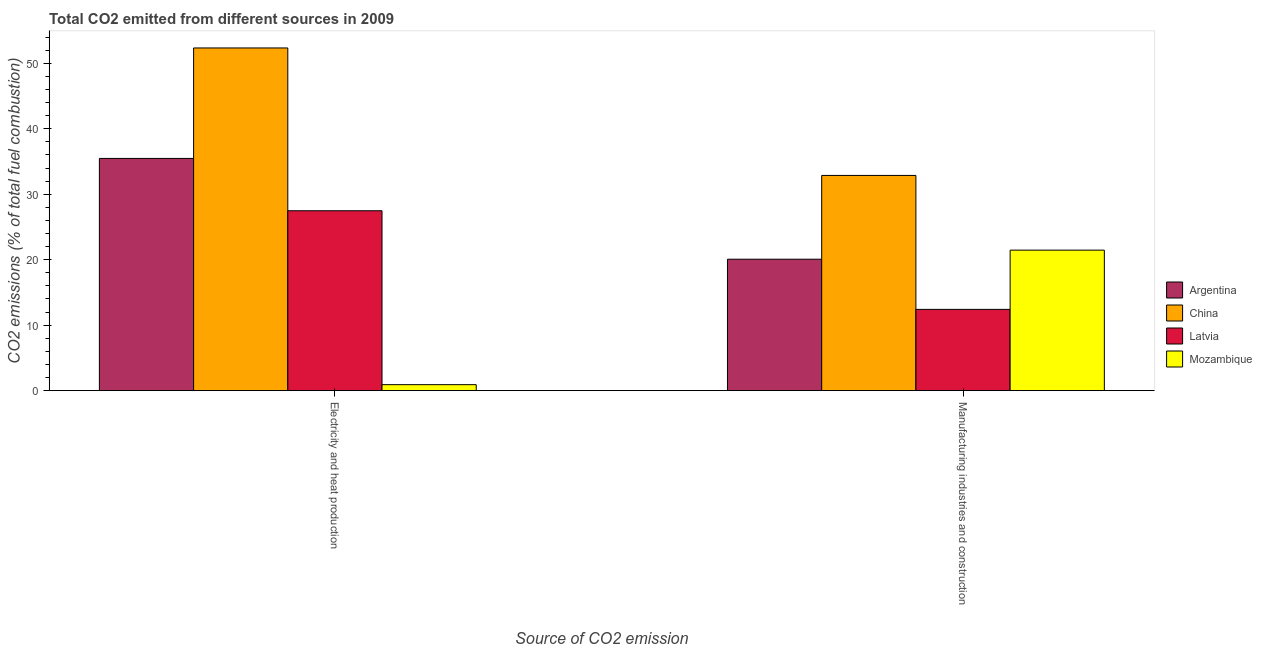How many different coloured bars are there?
Provide a short and direct response. 4. How many groups of bars are there?
Provide a short and direct response. 2. Are the number of bars per tick equal to the number of legend labels?
Provide a short and direct response. Yes. How many bars are there on the 1st tick from the left?
Give a very brief answer. 4. What is the label of the 1st group of bars from the left?
Keep it short and to the point. Electricity and heat production. What is the co2 emissions due to manufacturing industries in China?
Give a very brief answer. 32.87. Across all countries, what is the maximum co2 emissions due to electricity and heat production?
Ensure brevity in your answer.  52.34. Across all countries, what is the minimum co2 emissions due to electricity and heat production?
Give a very brief answer. 0.91. In which country was the co2 emissions due to electricity and heat production minimum?
Offer a terse response. Mozambique. What is the total co2 emissions due to manufacturing industries in the graph?
Offer a very short reply. 86.82. What is the difference between the co2 emissions due to manufacturing industries in China and that in Argentina?
Provide a short and direct response. 12.8. What is the difference between the co2 emissions due to manufacturing industries in Mozambique and the co2 emissions due to electricity and heat production in Latvia?
Make the answer very short. -6.01. What is the average co2 emissions due to manufacturing industries per country?
Your answer should be very brief. 21.71. What is the difference between the co2 emissions due to manufacturing industries and co2 emissions due to electricity and heat production in Argentina?
Provide a succinct answer. -15.39. What is the ratio of the co2 emissions due to electricity and heat production in Latvia to that in China?
Your answer should be compact. 0.52. Is the co2 emissions due to electricity and heat production in Mozambique less than that in Argentina?
Your answer should be very brief. Yes. In how many countries, is the co2 emissions due to manufacturing industries greater than the average co2 emissions due to manufacturing industries taken over all countries?
Keep it short and to the point. 1. What does the 3rd bar from the right in Electricity and heat production represents?
Your answer should be very brief. China. What is the title of the graph?
Give a very brief answer. Total CO2 emitted from different sources in 2009. Does "Germany" appear as one of the legend labels in the graph?
Your answer should be compact. No. What is the label or title of the X-axis?
Make the answer very short. Source of CO2 emission. What is the label or title of the Y-axis?
Your answer should be very brief. CO2 emissions (% of total fuel combustion). What is the CO2 emissions (% of total fuel combustion) of Argentina in Electricity and heat production?
Ensure brevity in your answer.  35.47. What is the CO2 emissions (% of total fuel combustion) of China in Electricity and heat production?
Keep it short and to the point. 52.34. What is the CO2 emissions (% of total fuel combustion) of Latvia in Electricity and heat production?
Offer a terse response. 27.48. What is the CO2 emissions (% of total fuel combustion) in Mozambique in Electricity and heat production?
Your answer should be compact. 0.91. What is the CO2 emissions (% of total fuel combustion) in Argentina in Manufacturing industries and construction?
Offer a very short reply. 20.08. What is the CO2 emissions (% of total fuel combustion) of China in Manufacturing industries and construction?
Keep it short and to the point. 32.87. What is the CO2 emissions (% of total fuel combustion) in Latvia in Manufacturing industries and construction?
Your answer should be compact. 12.41. What is the CO2 emissions (% of total fuel combustion) of Mozambique in Manufacturing industries and construction?
Your answer should be compact. 21.46. Across all Source of CO2 emission, what is the maximum CO2 emissions (% of total fuel combustion) of Argentina?
Keep it short and to the point. 35.47. Across all Source of CO2 emission, what is the maximum CO2 emissions (% of total fuel combustion) of China?
Your response must be concise. 52.34. Across all Source of CO2 emission, what is the maximum CO2 emissions (% of total fuel combustion) of Latvia?
Ensure brevity in your answer.  27.48. Across all Source of CO2 emission, what is the maximum CO2 emissions (% of total fuel combustion) in Mozambique?
Offer a very short reply. 21.46. Across all Source of CO2 emission, what is the minimum CO2 emissions (% of total fuel combustion) in Argentina?
Your answer should be very brief. 20.08. Across all Source of CO2 emission, what is the minimum CO2 emissions (% of total fuel combustion) of China?
Your answer should be compact. 32.87. Across all Source of CO2 emission, what is the minimum CO2 emissions (% of total fuel combustion) in Latvia?
Provide a succinct answer. 12.41. Across all Source of CO2 emission, what is the minimum CO2 emissions (% of total fuel combustion) of Mozambique?
Provide a short and direct response. 0.91. What is the total CO2 emissions (% of total fuel combustion) of Argentina in the graph?
Make the answer very short. 55.54. What is the total CO2 emissions (% of total fuel combustion) in China in the graph?
Offer a terse response. 85.21. What is the total CO2 emissions (% of total fuel combustion) in Latvia in the graph?
Give a very brief answer. 39.89. What is the total CO2 emissions (% of total fuel combustion) in Mozambique in the graph?
Make the answer very short. 22.37. What is the difference between the CO2 emissions (% of total fuel combustion) of Argentina in Electricity and heat production and that in Manufacturing industries and construction?
Your answer should be compact. 15.39. What is the difference between the CO2 emissions (% of total fuel combustion) in China in Electricity and heat production and that in Manufacturing industries and construction?
Your response must be concise. 19.47. What is the difference between the CO2 emissions (% of total fuel combustion) in Latvia in Electricity and heat production and that in Manufacturing industries and construction?
Your response must be concise. 15.06. What is the difference between the CO2 emissions (% of total fuel combustion) of Mozambique in Electricity and heat production and that in Manufacturing industries and construction?
Your answer should be very brief. -20.55. What is the difference between the CO2 emissions (% of total fuel combustion) in Argentina in Electricity and heat production and the CO2 emissions (% of total fuel combustion) in China in Manufacturing industries and construction?
Provide a short and direct response. 2.6. What is the difference between the CO2 emissions (% of total fuel combustion) in Argentina in Electricity and heat production and the CO2 emissions (% of total fuel combustion) in Latvia in Manufacturing industries and construction?
Offer a very short reply. 23.05. What is the difference between the CO2 emissions (% of total fuel combustion) of Argentina in Electricity and heat production and the CO2 emissions (% of total fuel combustion) of Mozambique in Manufacturing industries and construction?
Provide a succinct answer. 14.01. What is the difference between the CO2 emissions (% of total fuel combustion) of China in Electricity and heat production and the CO2 emissions (% of total fuel combustion) of Latvia in Manufacturing industries and construction?
Ensure brevity in your answer.  39.93. What is the difference between the CO2 emissions (% of total fuel combustion) in China in Electricity and heat production and the CO2 emissions (% of total fuel combustion) in Mozambique in Manufacturing industries and construction?
Give a very brief answer. 30.88. What is the difference between the CO2 emissions (% of total fuel combustion) in Latvia in Electricity and heat production and the CO2 emissions (% of total fuel combustion) in Mozambique in Manufacturing industries and construction?
Provide a succinct answer. 6.01. What is the average CO2 emissions (% of total fuel combustion) in Argentina per Source of CO2 emission?
Keep it short and to the point. 27.77. What is the average CO2 emissions (% of total fuel combustion) in China per Source of CO2 emission?
Provide a short and direct response. 42.61. What is the average CO2 emissions (% of total fuel combustion) in Latvia per Source of CO2 emission?
Offer a very short reply. 19.94. What is the average CO2 emissions (% of total fuel combustion) of Mozambique per Source of CO2 emission?
Provide a short and direct response. 11.19. What is the difference between the CO2 emissions (% of total fuel combustion) in Argentina and CO2 emissions (% of total fuel combustion) in China in Electricity and heat production?
Your response must be concise. -16.87. What is the difference between the CO2 emissions (% of total fuel combustion) of Argentina and CO2 emissions (% of total fuel combustion) of Latvia in Electricity and heat production?
Ensure brevity in your answer.  7.99. What is the difference between the CO2 emissions (% of total fuel combustion) of Argentina and CO2 emissions (% of total fuel combustion) of Mozambique in Electricity and heat production?
Keep it short and to the point. 34.55. What is the difference between the CO2 emissions (% of total fuel combustion) of China and CO2 emissions (% of total fuel combustion) of Latvia in Electricity and heat production?
Offer a terse response. 24.86. What is the difference between the CO2 emissions (% of total fuel combustion) in China and CO2 emissions (% of total fuel combustion) in Mozambique in Electricity and heat production?
Provide a succinct answer. 51.43. What is the difference between the CO2 emissions (% of total fuel combustion) of Latvia and CO2 emissions (% of total fuel combustion) of Mozambique in Electricity and heat production?
Your answer should be very brief. 26.56. What is the difference between the CO2 emissions (% of total fuel combustion) of Argentina and CO2 emissions (% of total fuel combustion) of China in Manufacturing industries and construction?
Your response must be concise. -12.8. What is the difference between the CO2 emissions (% of total fuel combustion) of Argentina and CO2 emissions (% of total fuel combustion) of Latvia in Manufacturing industries and construction?
Your answer should be very brief. 7.66. What is the difference between the CO2 emissions (% of total fuel combustion) in Argentina and CO2 emissions (% of total fuel combustion) in Mozambique in Manufacturing industries and construction?
Make the answer very short. -1.39. What is the difference between the CO2 emissions (% of total fuel combustion) in China and CO2 emissions (% of total fuel combustion) in Latvia in Manufacturing industries and construction?
Your response must be concise. 20.46. What is the difference between the CO2 emissions (% of total fuel combustion) of China and CO2 emissions (% of total fuel combustion) of Mozambique in Manufacturing industries and construction?
Provide a short and direct response. 11.41. What is the difference between the CO2 emissions (% of total fuel combustion) of Latvia and CO2 emissions (% of total fuel combustion) of Mozambique in Manufacturing industries and construction?
Give a very brief answer. -9.05. What is the ratio of the CO2 emissions (% of total fuel combustion) in Argentina in Electricity and heat production to that in Manufacturing industries and construction?
Make the answer very short. 1.77. What is the ratio of the CO2 emissions (% of total fuel combustion) of China in Electricity and heat production to that in Manufacturing industries and construction?
Ensure brevity in your answer.  1.59. What is the ratio of the CO2 emissions (% of total fuel combustion) of Latvia in Electricity and heat production to that in Manufacturing industries and construction?
Your answer should be compact. 2.21. What is the ratio of the CO2 emissions (% of total fuel combustion) of Mozambique in Electricity and heat production to that in Manufacturing industries and construction?
Your response must be concise. 0.04. What is the difference between the highest and the second highest CO2 emissions (% of total fuel combustion) in Argentina?
Offer a terse response. 15.39. What is the difference between the highest and the second highest CO2 emissions (% of total fuel combustion) of China?
Provide a short and direct response. 19.47. What is the difference between the highest and the second highest CO2 emissions (% of total fuel combustion) of Latvia?
Make the answer very short. 15.06. What is the difference between the highest and the second highest CO2 emissions (% of total fuel combustion) in Mozambique?
Your response must be concise. 20.55. What is the difference between the highest and the lowest CO2 emissions (% of total fuel combustion) in Argentina?
Keep it short and to the point. 15.39. What is the difference between the highest and the lowest CO2 emissions (% of total fuel combustion) of China?
Your answer should be compact. 19.47. What is the difference between the highest and the lowest CO2 emissions (% of total fuel combustion) in Latvia?
Make the answer very short. 15.06. What is the difference between the highest and the lowest CO2 emissions (% of total fuel combustion) of Mozambique?
Provide a succinct answer. 20.55. 